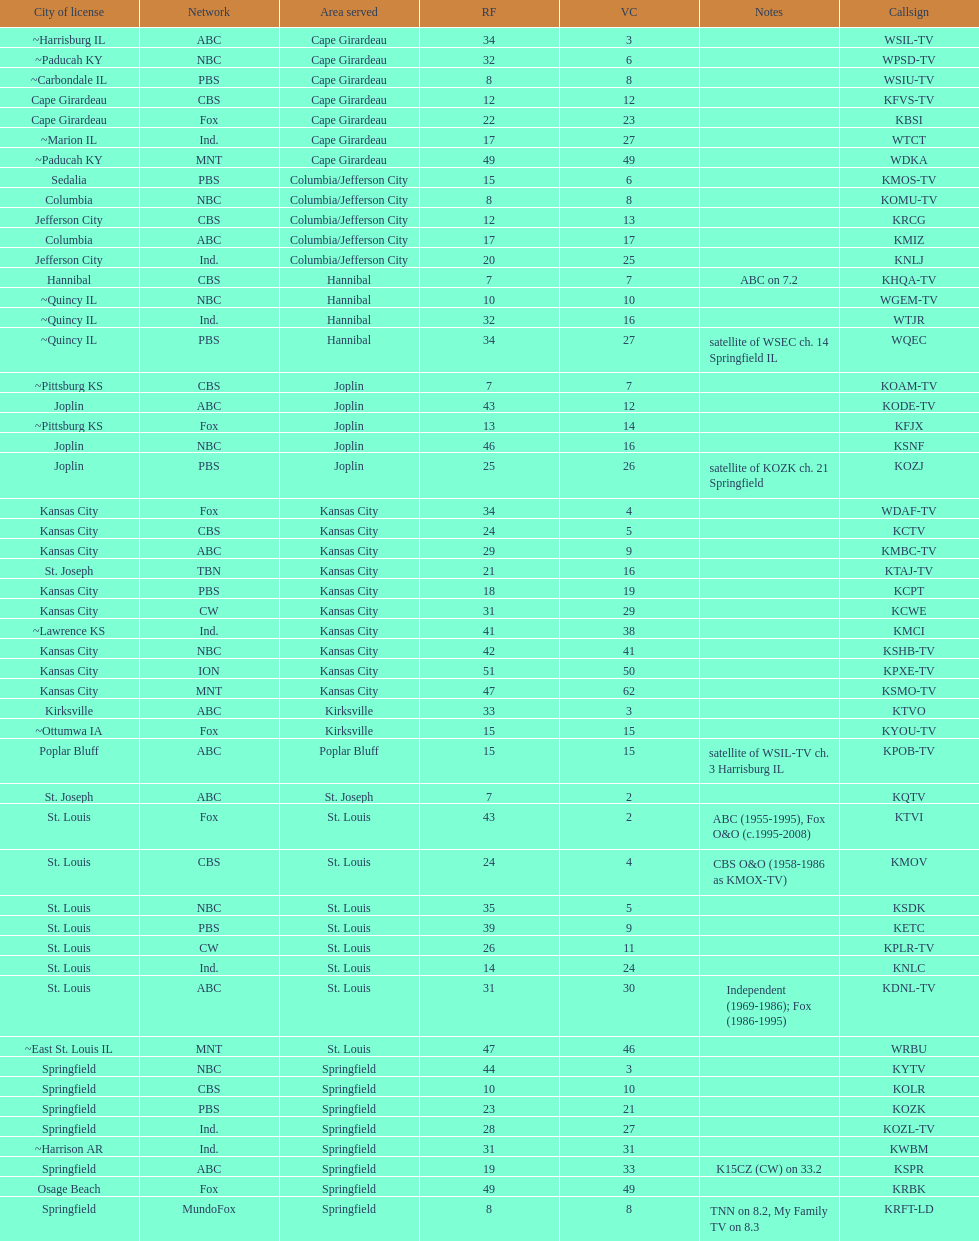What is the total number of stations under the cbs network? 7. 